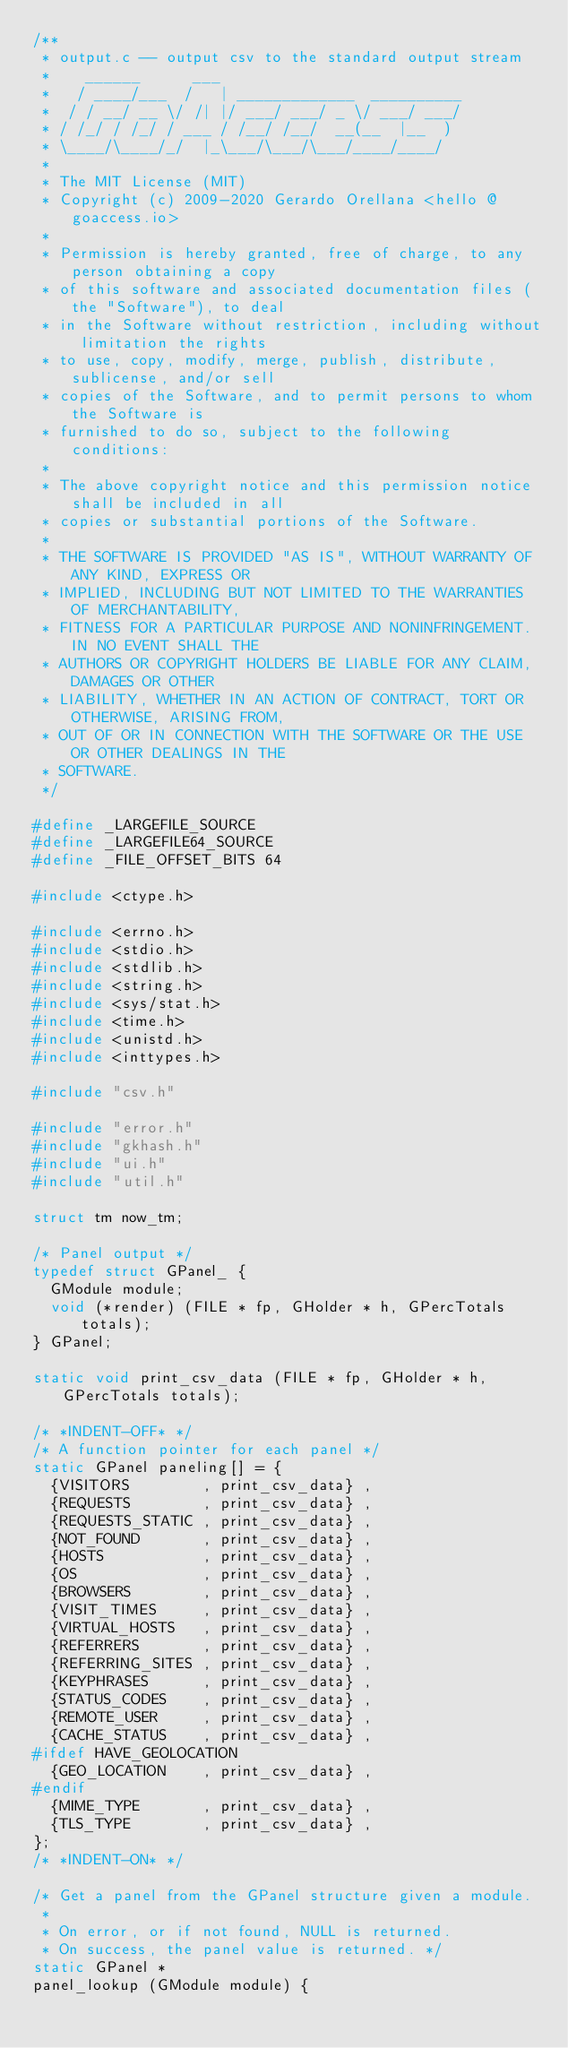<code> <loc_0><loc_0><loc_500><loc_500><_C_>/**
 * output.c -- output csv to the standard output stream
 *    ______      ___
 *   / ____/___  /   | _____________  __________
 *  / / __/ __ \/ /| |/ ___/ ___/ _ \/ ___/ ___/
 * / /_/ / /_/ / ___ / /__/ /__/  __(__  |__  )
 * \____/\____/_/  |_\___/\___/\___/____/____/
 *
 * The MIT License (MIT)
 * Copyright (c) 2009-2020 Gerardo Orellana <hello @ goaccess.io>
 *
 * Permission is hereby granted, free of charge, to any person obtaining a copy
 * of this software and associated documentation files (the "Software"), to deal
 * in the Software without restriction, including without limitation the rights
 * to use, copy, modify, merge, publish, distribute, sublicense, and/or sell
 * copies of the Software, and to permit persons to whom the Software is
 * furnished to do so, subject to the following conditions:
 *
 * The above copyright notice and this permission notice shall be included in all
 * copies or substantial portions of the Software.
 *
 * THE SOFTWARE IS PROVIDED "AS IS", WITHOUT WARRANTY OF ANY KIND, EXPRESS OR
 * IMPLIED, INCLUDING BUT NOT LIMITED TO THE WARRANTIES OF MERCHANTABILITY,
 * FITNESS FOR A PARTICULAR PURPOSE AND NONINFRINGEMENT. IN NO EVENT SHALL THE
 * AUTHORS OR COPYRIGHT HOLDERS BE LIABLE FOR ANY CLAIM, DAMAGES OR OTHER
 * LIABILITY, WHETHER IN AN ACTION OF CONTRACT, TORT OR OTHERWISE, ARISING FROM,
 * OUT OF OR IN CONNECTION WITH THE SOFTWARE OR THE USE OR OTHER DEALINGS IN THE
 * SOFTWARE.
 */

#define _LARGEFILE_SOURCE
#define _LARGEFILE64_SOURCE
#define _FILE_OFFSET_BITS 64

#include <ctype.h>

#include <errno.h>
#include <stdio.h>
#include <stdlib.h>
#include <string.h>
#include <sys/stat.h>
#include <time.h>
#include <unistd.h>
#include <inttypes.h>

#include "csv.h"

#include "error.h"
#include "gkhash.h"
#include "ui.h"
#include "util.h"

struct tm now_tm;

/* Panel output */
typedef struct GPanel_ {
  GModule module;
  void (*render) (FILE * fp, GHolder * h, GPercTotals totals);
} GPanel;

static void print_csv_data (FILE * fp, GHolder * h, GPercTotals totals);

/* *INDENT-OFF* */
/* A function pointer for each panel */
static GPanel paneling[] = {
  {VISITORS        , print_csv_data} ,
  {REQUESTS        , print_csv_data} ,
  {REQUESTS_STATIC , print_csv_data} ,
  {NOT_FOUND       , print_csv_data} ,
  {HOSTS           , print_csv_data} ,
  {OS              , print_csv_data} ,
  {BROWSERS        , print_csv_data} ,
  {VISIT_TIMES     , print_csv_data} ,
  {VIRTUAL_HOSTS   , print_csv_data} ,
  {REFERRERS       , print_csv_data} ,
  {REFERRING_SITES , print_csv_data} ,
  {KEYPHRASES      , print_csv_data} ,
  {STATUS_CODES    , print_csv_data} ,
  {REMOTE_USER     , print_csv_data} ,
  {CACHE_STATUS    , print_csv_data} ,
#ifdef HAVE_GEOLOCATION
  {GEO_LOCATION    , print_csv_data} ,
#endif
  {MIME_TYPE       , print_csv_data} ,
  {TLS_TYPE        , print_csv_data} ,
};
/* *INDENT-ON* */

/* Get a panel from the GPanel structure given a module.
 *
 * On error, or if not found, NULL is returned.
 * On success, the panel value is returned. */
static GPanel *
panel_lookup (GModule module) {</code> 